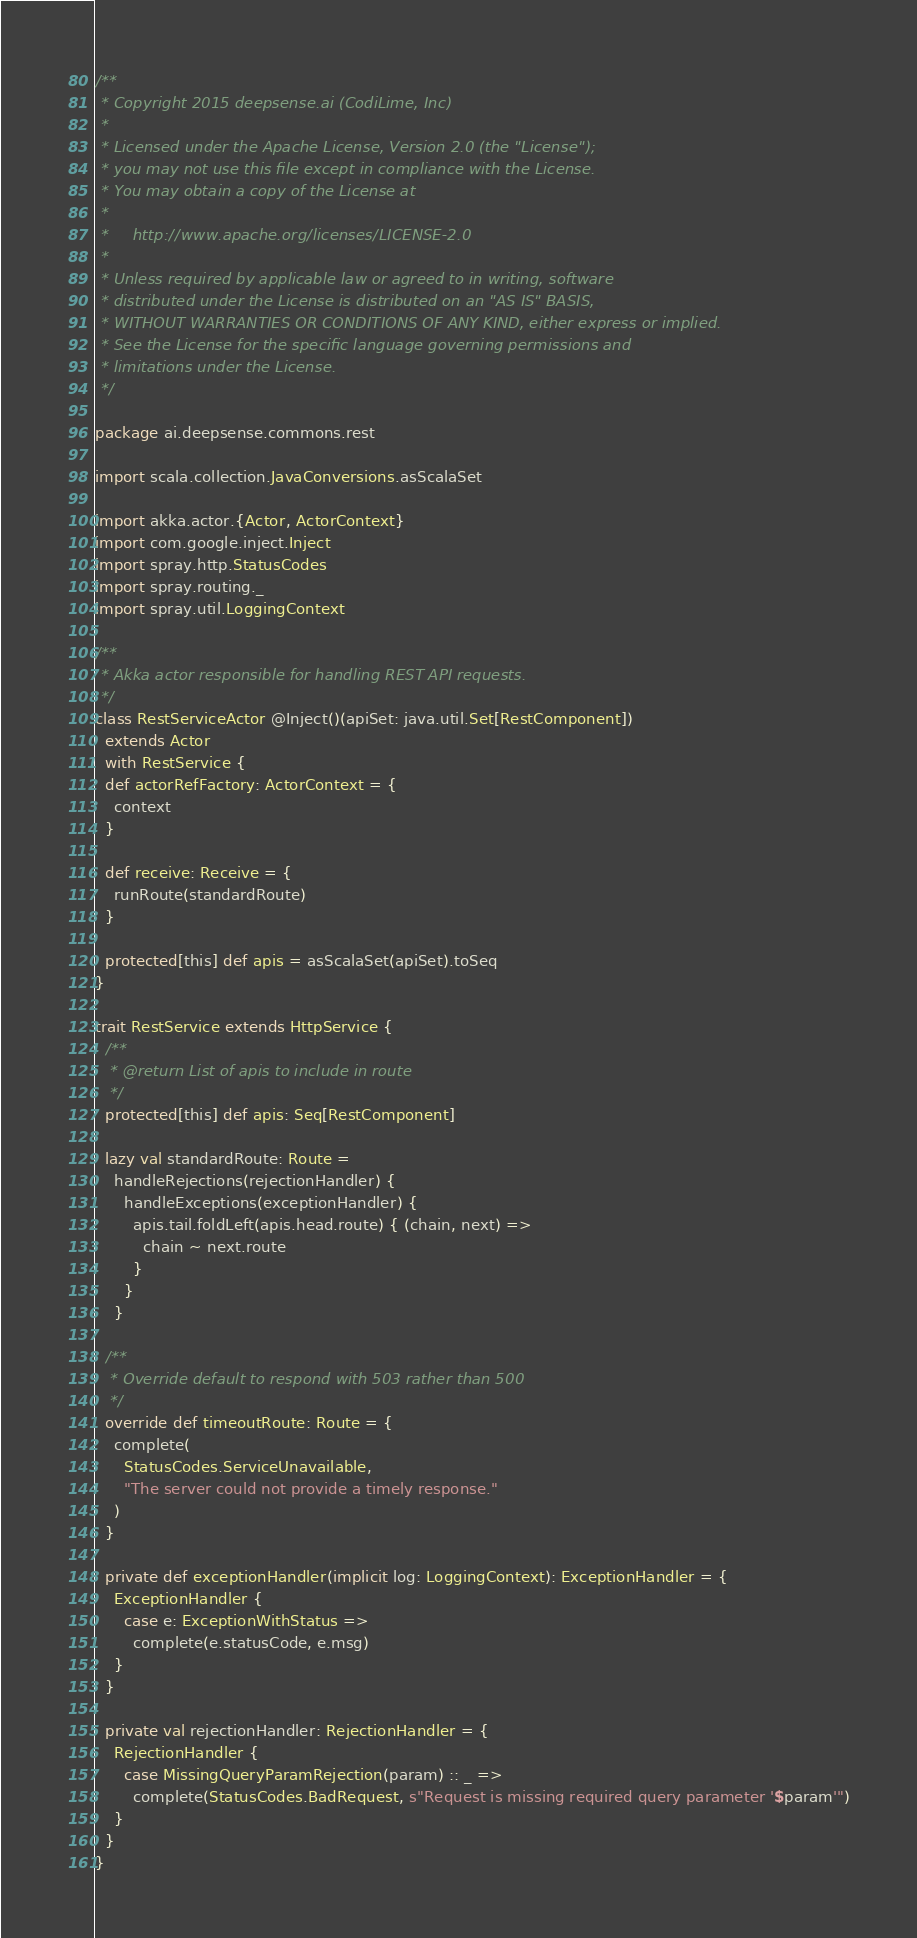<code> <loc_0><loc_0><loc_500><loc_500><_Scala_>/**
 * Copyright 2015 deepsense.ai (CodiLime, Inc)
 *
 * Licensed under the Apache License, Version 2.0 (the "License");
 * you may not use this file except in compliance with the License.
 * You may obtain a copy of the License at
 *
 *     http://www.apache.org/licenses/LICENSE-2.0
 *
 * Unless required by applicable law or agreed to in writing, software
 * distributed under the License is distributed on an "AS IS" BASIS,
 * WITHOUT WARRANTIES OR CONDITIONS OF ANY KIND, either express or implied.
 * See the License for the specific language governing permissions and
 * limitations under the License.
 */

package ai.deepsense.commons.rest

import scala.collection.JavaConversions.asScalaSet

import akka.actor.{Actor, ActorContext}
import com.google.inject.Inject
import spray.http.StatusCodes
import spray.routing._
import spray.util.LoggingContext

/**
 * Akka actor responsible for handling REST API requests.
 */
class RestServiceActor @Inject()(apiSet: java.util.Set[RestComponent])
  extends Actor
  with RestService {
  def actorRefFactory: ActorContext = {
    context
  }

  def receive: Receive = {
    runRoute(standardRoute)
  }

  protected[this] def apis = asScalaSet(apiSet).toSeq
}

trait RestService extends HttpService {
  /**
   * @return List of apis to include in route
   */
  protected[this] def apis: Seq[RestComponent]

  lazy val standardRoute: Route =
    handleRejections(rejectionHandler) {
      handleExceptions(exceptionHandler) {
        apis.tail.foldLeft(apis.head.route) { (chain, next) =>
          chain ~ next.route
        }
      }
    }

  /**
   * Override default to respond with 503 rather than 500
   */
  override def timeoutRoute: Route = {
    complete(
      StatusCodes.ServiceUnavailable,
      "The server could not provide a timely response."
    )
  }

  private def exceptionHandler(implicit log: LoggingContext): ExceptionHandler = {
    ExceptionHandler {
      case e: ExceptionWithStatus =>
        complete(e.statusCode, e.msg)
    }
  }

  private val rejectionHandler: RejectionHandler = {
    RejectionHandler {
      case MissingQueryParamRejection(param) :: _ =>
        complete(StatusCodes.BadRequest, s"Request is missing required query parameter '$param'")
    }
  }
}
</code> 